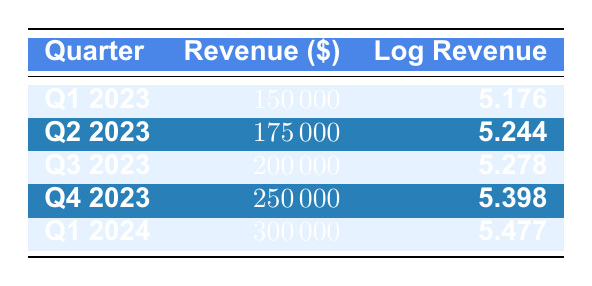What was the revenue in Q4 2023? The table shows that for Q4 2023, the revenue is listed as 250000.
Answer: 250000 What is the log revenue for Q2 2023? According to the table, the log revenue for Q2 2023 is 5.244.
Answer: 5.244 What is the total revenue for Q3 2023 and Q4 2023 combined? The revenue for Q3 2023 is 200000 and for Q4 2023 is 250000. Adding both gives 200000 + 250000 = 450000.
Answer: 450000 Is the revenue in Q1 2024 higher than in Q1 2023? The revenue in Q1 2024 is 300000 and in Q1 2023 is 150000. Since 300000 is greater than 150000, the statement is true.
Answer: Yes What is the average log revenue for the first quarter of 2023 and the first quarter of 2024? The log revenue for Q1 2023 is 5.176, and for Q1 2024, it is 5.477. The average is (5.176 + 5.477) / 2 = 5.3265.
Answer: 5.3265 In which quarter did the revenue grow the most compared to the previous quarter? The revenue growth from Q3 2023 to Q4 2023 is 250000 - 200000 = 50000, which is the largest increase compared to the other quarters’ transitions.
Answer: Q4 2023 What is the difference in log revenue between Q1 2024 and Q2 2023? The log revenue for Q1 2024 is 5.477 and for Q2 2023 is 5.244. The difference is 5.477 - 5.244 = 0.233.
Answer: 0.233 Did the revenue show a consistent quarterly increase across all periods? Checking the revenues: 150000, 175000, 200000, 250000, 300000 shows that there was an increase each quarter. Hence, the revenue did increase consistently.
Answer: Yes 